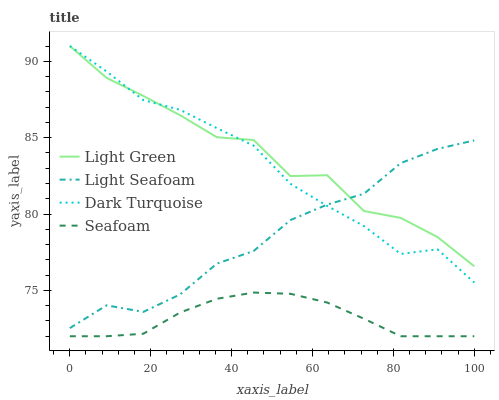Does Seafoam have the minimum area under the curve?
Answer yes or no. Yes. Does Light Green have the maximum area under the curve?
Answer yes or no. Yes. Does Light Seafoam have the minimum area under the curve?
Answer yes or no. No. Does Light Seafoam have the maximum area under the curve?
Answer yes or no. No. Is Seafoam the smoothest?
Answer yes or no. Yes. Is Light Green the roughest?
Answer yes or no. Yes. Is Light Seafoam the smoothest?
Answer yes or no. No. Is Light Seafoam the roughest?
Answer yes or no. No. Does Seafoam have the lowest value?
Answer yes or no. Yes. Does Light Seafoam have the lowest value?
Answer yes or no. No. Does Light Green have the highest value?
Answer yes or no. Yes. Does Light Seafoam have the highest value?
Answer yes or no. No. Is Seafoam less than Dark Turquoise?
Answer yes or no. Yes. Is Light Green greater than Seafoam?
Answer yes or no. Yes. Does Light Seafoam intersect Light Green?
Answer yes or no. Yes. Is Light Seafoam less than Light Green?
Answer yes or no. No. Is Light Seafoam greater than Light Green?
Answer yes or no. No. Does Seafoam intersect Dark Turquoise?
Answer yes or no. No. 